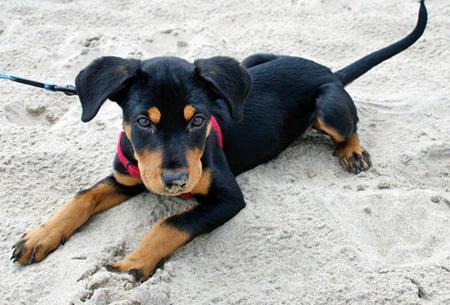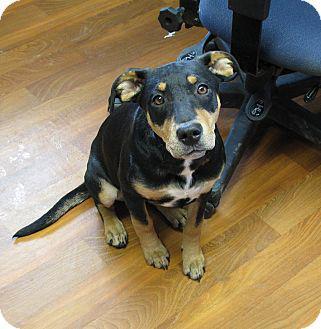The first image is the image on the left, the second image is the image on the right. Considering the images on both sides, is "The right image shows a forward-facing reclining two-tone adult doberman with erect pointy ears." valid? Answer yes or no. No. The first image is the image on the left, the second image is the image on the right. Considering the images on both sides, is "One Doberman's ears are both raised." valid? Answer yes or no. No. 